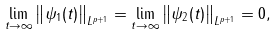Convert formula to latex. <formula><loc_0><loc_0><loc_500><loc_500>\lim _ { t \to \infty } \left \| \psi _ { 1 } ( t ) \right \| _ { L ^ { p + 1 } } = \lim _ { t \to \infty } \left \| \psi _ { 2 } ( t ) \right \| _ { L ^ { p + 1 } } = 0 ,</formula> 